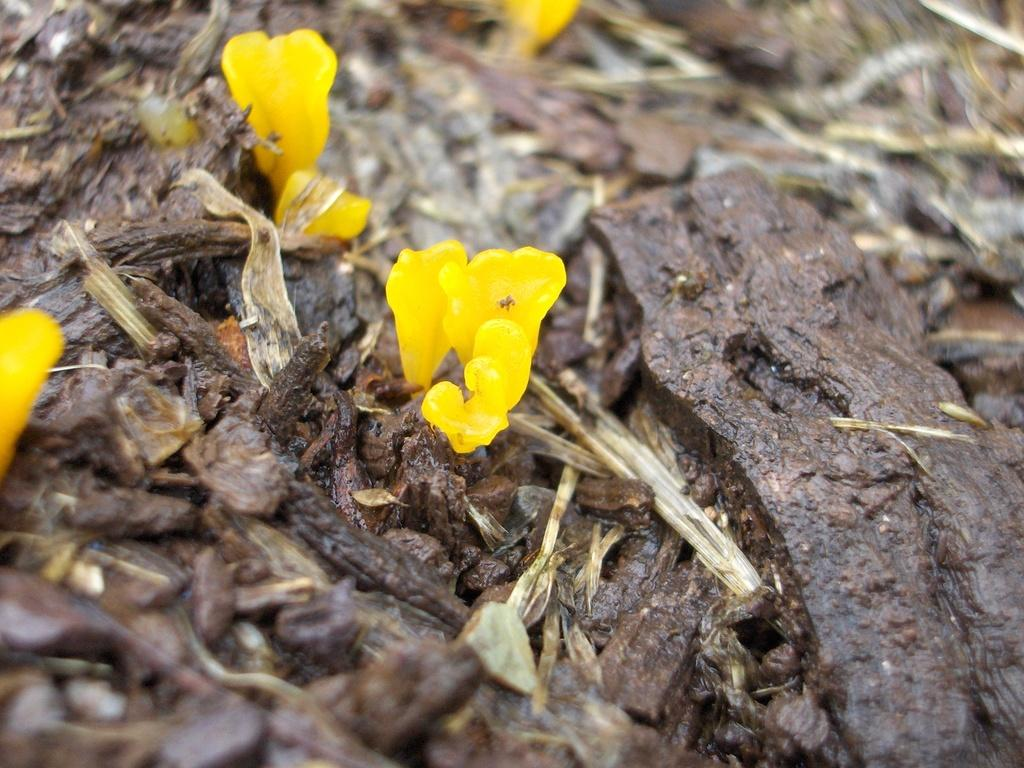What type of plants can be seen in the image? There are flowers in the image. What other objects are present in the image? There are rocks and wooden sticks in the image. Can you describe the background of the image? The background of the image is blurred. What type of ring can be seen on the wooden stick in the image? There is no ring present on the wooden stick in the image. 